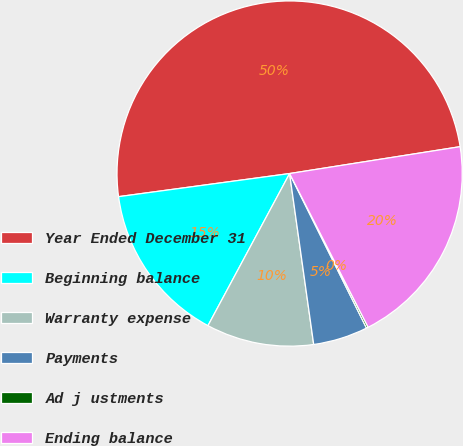<chart> <loc_0><loc_0><loc_500><loc_500><pie_chart><fcel>Year Ended December 31<fcel>Beginning balance<fcel>Warranty expense<fcel>Payments<fcel>Ad j ustments<fcel>Ending balance<nl><fcel>49.65%<fcel>15.02%<fcel>10.07%<fcel>5.12%<fcel>0.17%<fcel>19.97%<nl></chart> 